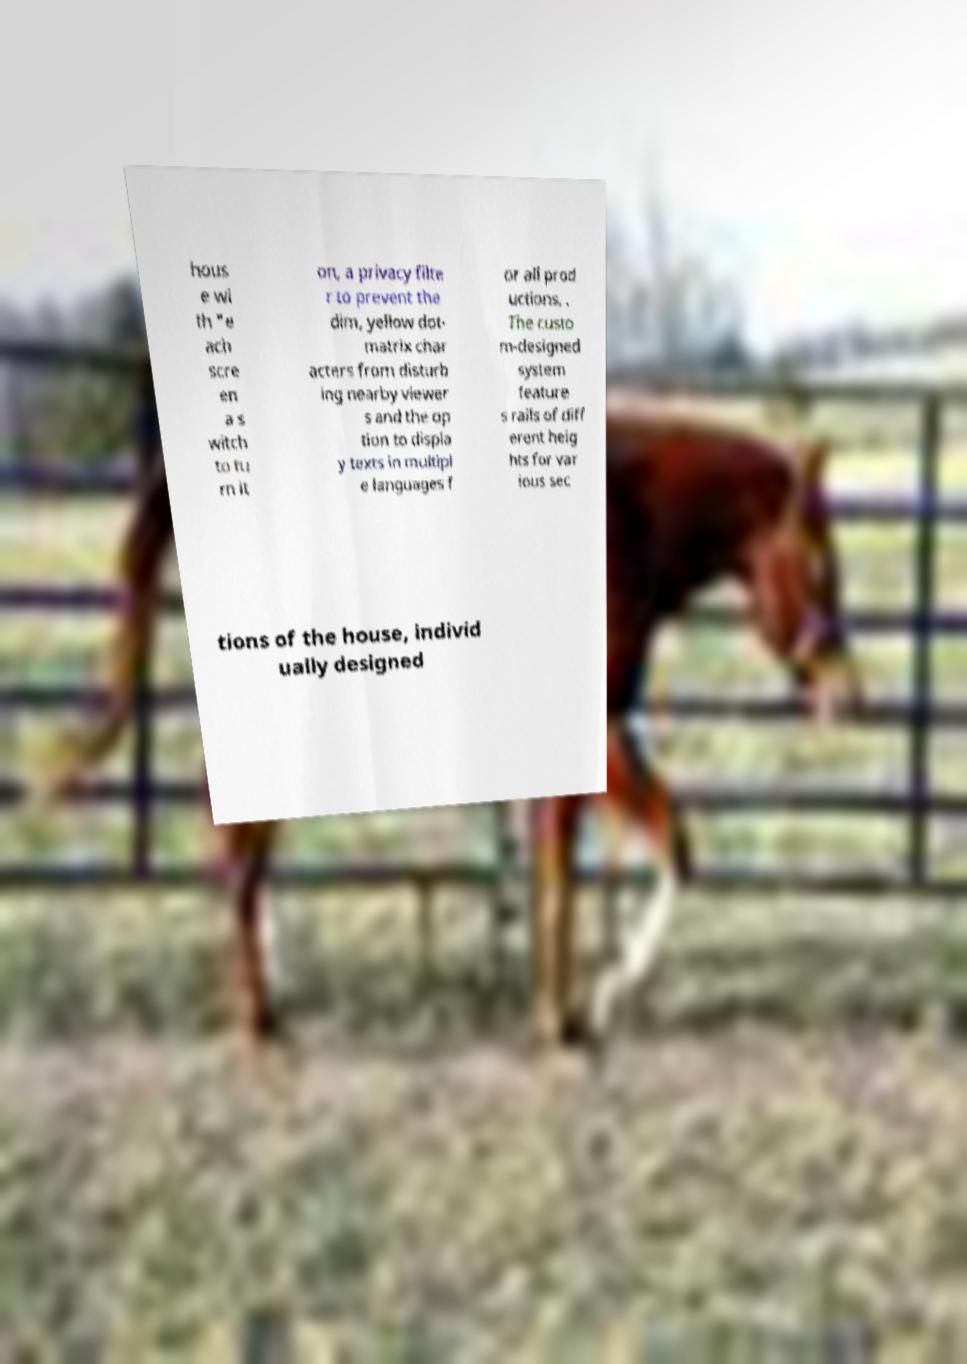What messages or text are displayed in this image? I need them in a readable, typed format. hous e wi th "e ach scre en a s witch to tu rn it on, a privacy filte r to prevent the dim, yellow dot- matrix char acters from disturb ing nearby viewer s and the op tion to displa y texts in multipl e languages f or all prod uctions, . The custo m-designed system feature s rails of diff erent heig hts for var ious sec tions of the house, individ ually designed 